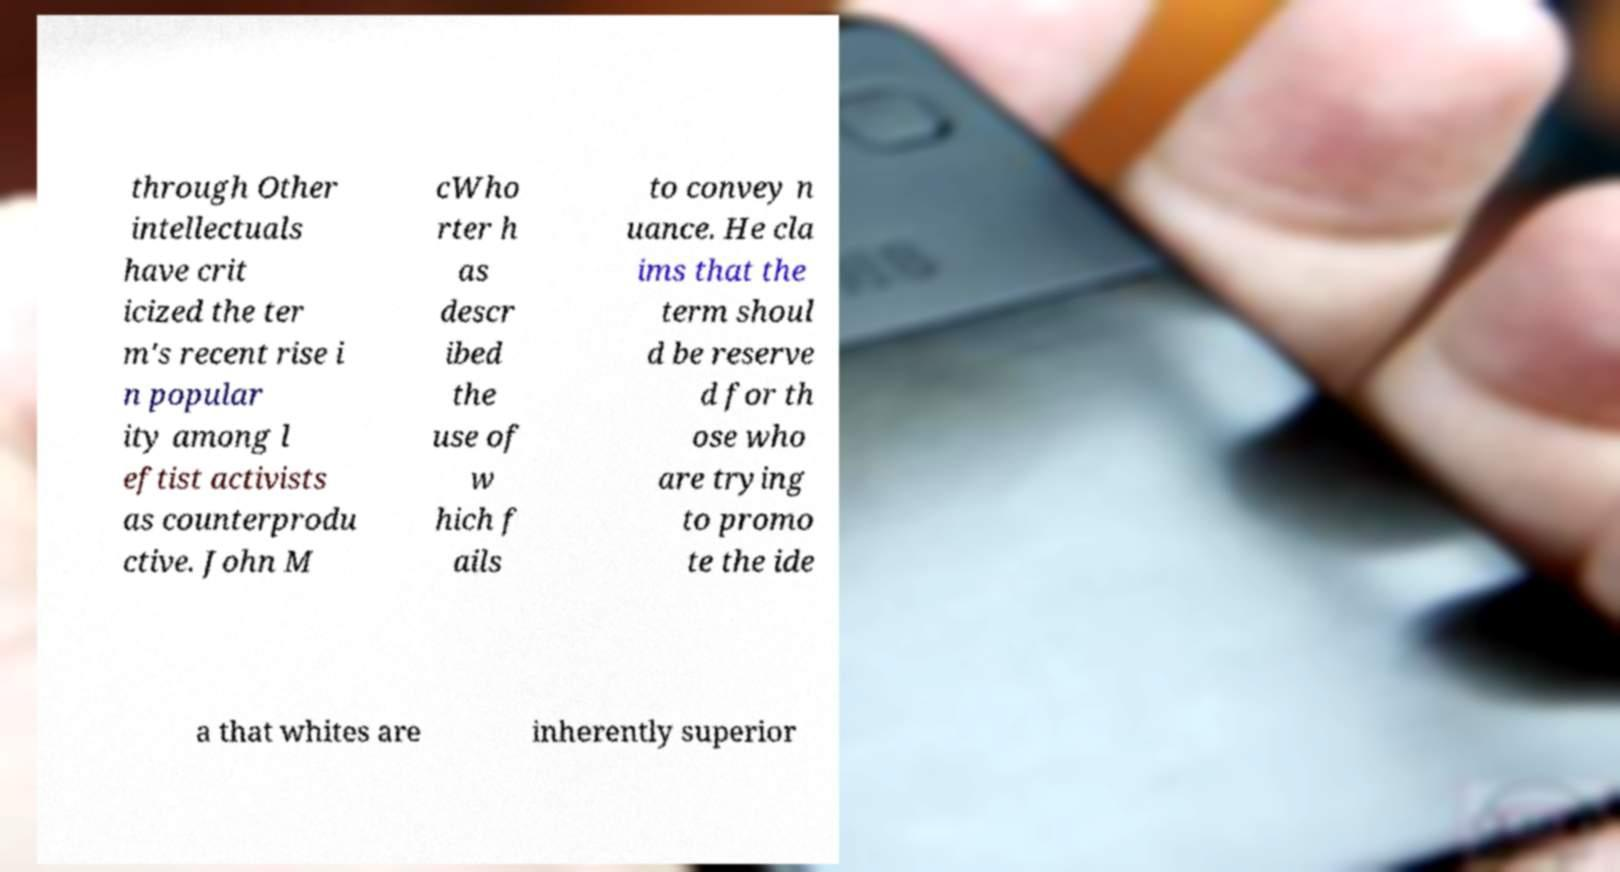Can you accurately transcribe the text from the provided image for me? through Other intellectuals have crit icized the ter m's recent rise i n popular ity among l eftist activists as counterprodu ctive. John M cWho rter h as descr ibed the use of w hich f ails to convey n uance. He cla ims that the term shoul d be reserve d for th ose who are trying to promo te the ide a that whites are inherently superior 